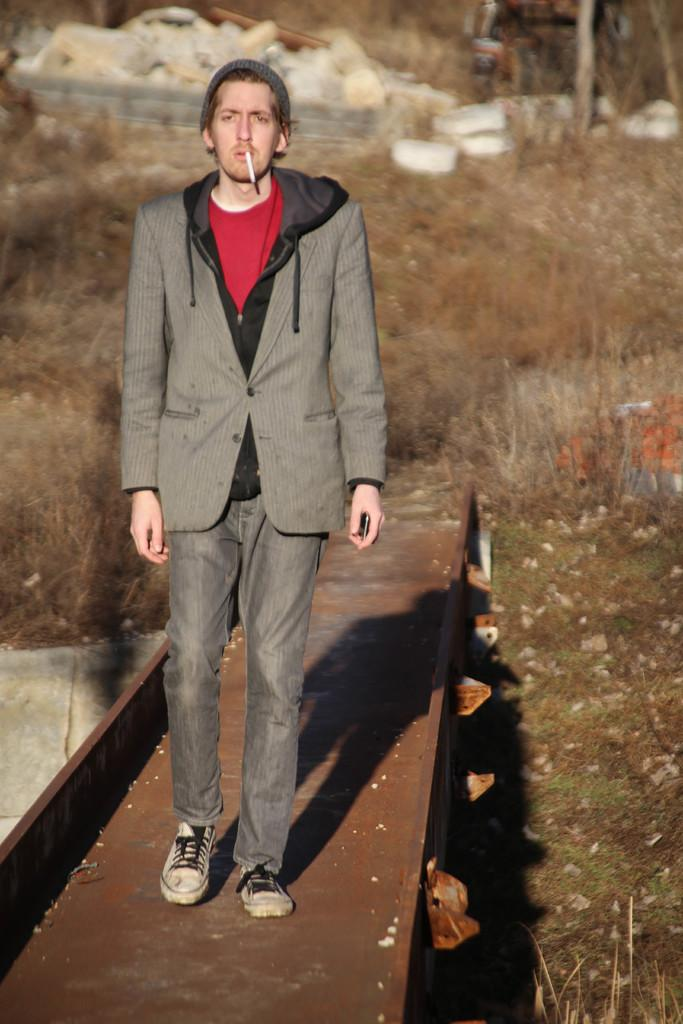What is the main subject of the image? There is a person in the image. What is the person wearing? The person is wearing a suit. What is the person doing in the image? The person is walking on a walkway. What can be seen in the background of the image? There is grass, stones, and trees in the background of the image. How does the person increase the speed of their walking in the image? The image does not show the person increasing their walking speed, as it only captures a single moment in time. What type of vehicle is the person driving in the image? There is no vehicle present in the image; the person is walking on a walkway. 